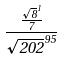<formula> <loc_0><loc_0><loc_500><loc_500>\frac { \frac { \sqrt { 8 } ^ { 1 } } { 7 } } { \sqrt { 2 0 2 } ^ { 9 5 } }</formula> 